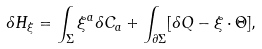Convert formula to latex. <formula><loc_0><loc_0><loc_500><loc_500>\delta H _ { \xi } = \int _ { \Sigma } \xi ^ { a } \delta C _ { a } + \int _ { \partial \Sigma } [ \delta Q - \xi \cdot \Theta ] ,</formula> 